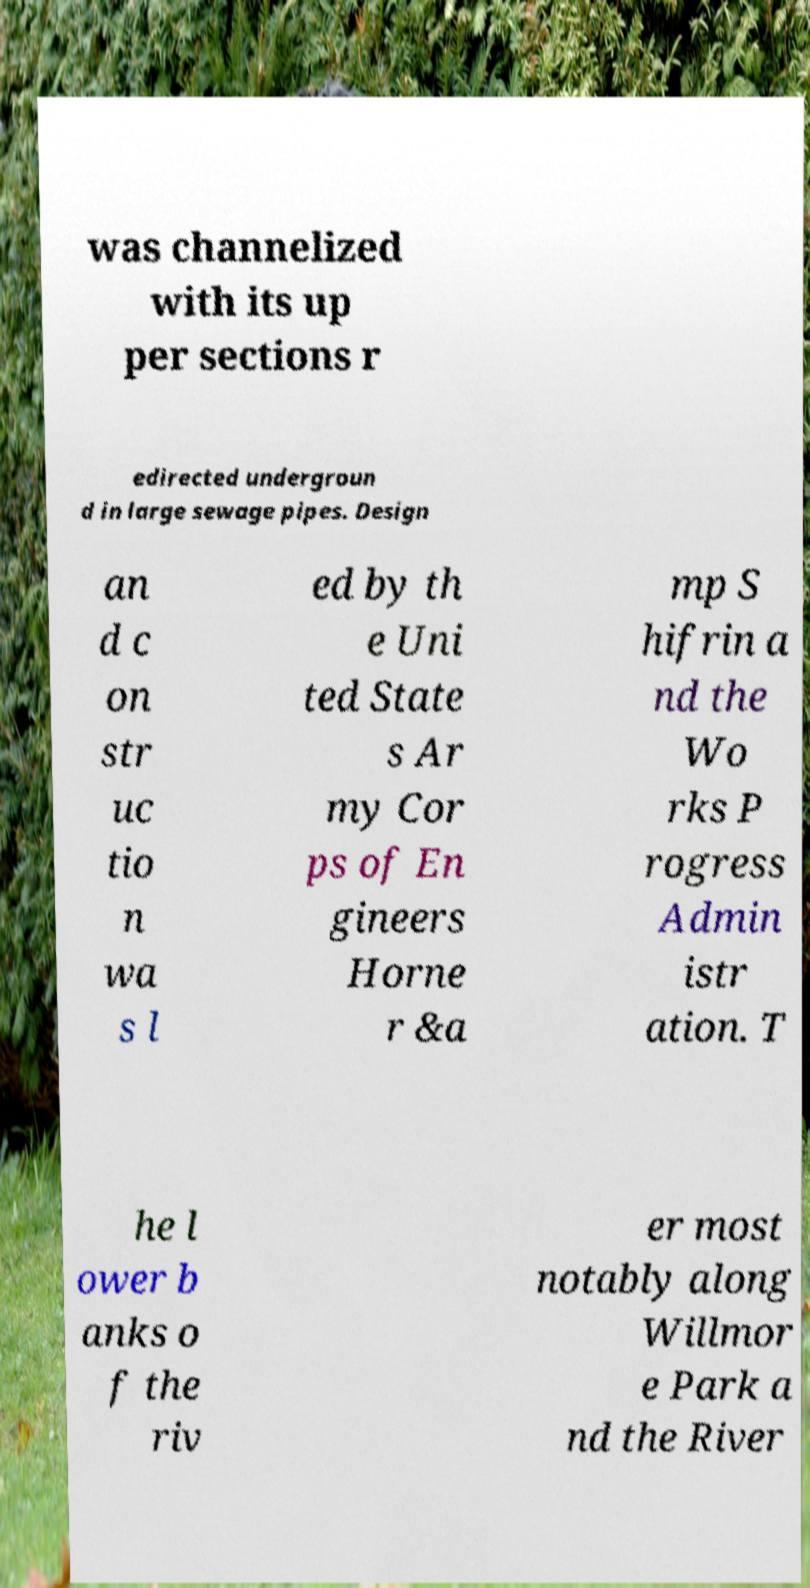Please read and relay the text visible in this image. What does it say? was channelized with its up per sections r edirected undergroun d in large sewage pipes. Design an d c on str uc tio n wa s l ed by th e Uni ted State s Ar my Cor ps of En gineers Horne r &a mp S hifrin a nd the Wo rks P rogress Admin istr ation. T he l ower b anks o f the riv er most notably along Willmor e Park a nd the River 